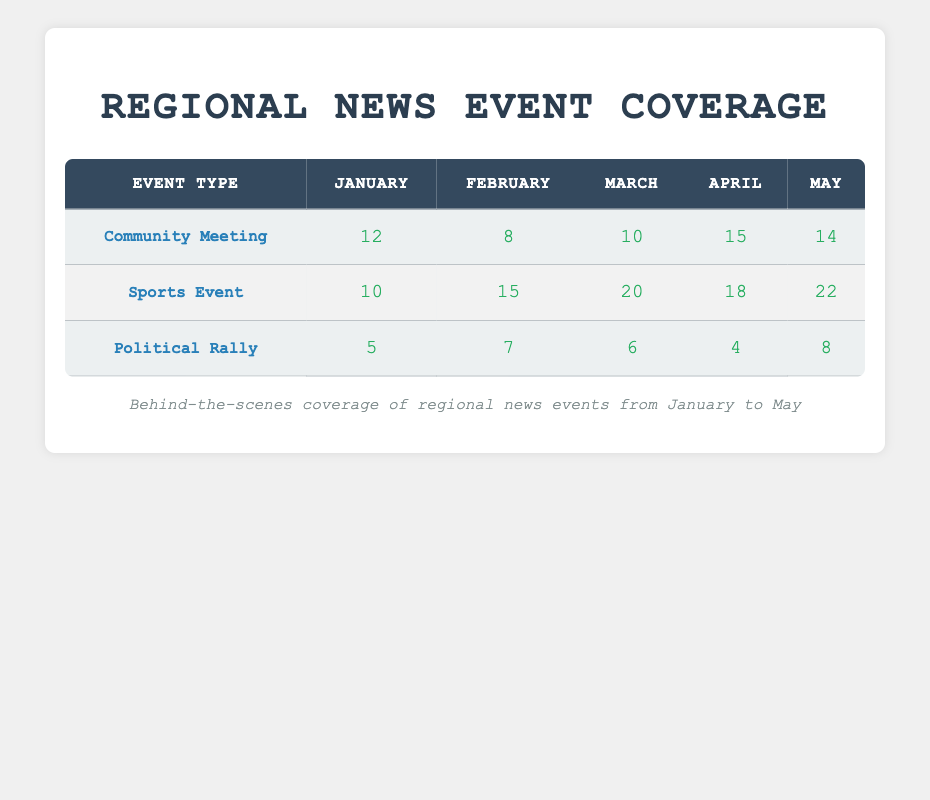What is the total count of Community Meetings in April? From the table, the count of Community Meetings in April is 15. There are no other counts to consider for this question.
Answer: 15 Which month had the highest number of Sports Events? Looking at the table, the counts for Sports Events by month are: January (10), February (15), March (20), April (18), and May (22). The highest count is 22 in May.
Answer: May How many more Community Meetings were covered in January compared to February? The count of Community Meetings in January is 12 and in February is 8. To find the difference, subtract February's count from January's count: 12 - 8 = 4.
Answer: 4 Did the number of Political Rallies increase from January to May? The counts for Political Rallies by month are: January (5), February (7), March (6), April (4), and May (8). Comparing these values, January to February shows an increase (from 5 to 7), then decreases in March and April, before increasing again in May. Hence, it did not consistently increase.
Answer: No What is the average count of Sports Events across all months? To find the average, we sum the counts for Sports Events from all months: 10 (January) + 15 (February) + 20 (March) + 18 (April) + 22 (May) = 85. There are 5 months, so we divide 85 by 5 to get an average of 17.
Answer: 17 How many total events were reported in March? The counts for all event types in March are: Community Meeting (10), Sports Event (20), and Political Rally (6). Adding these counts gives: 10 + 20 + 6 = 36.
Answer: 36 Which month had the least number of Political Rallies? By checking the table, the counts for Political Rallies by month are: January (5), February (7), March (6), April (4), and May (8). The least count is 4 in April.
Answer: April Was there a month where the count of Community Meetings exceeded 15? The counts for Community Meetings are: January (12), February (8), March (10), April (15), and May (14). Since 15 is the highest count and no month exceeds this, the answer is no.
Answer: No In which month did the total coverage count (sum of all events) exceed 40? Calculating the total counts for each month: January (12 + 10 + 5 = 27), February (8 + 15 + 7 = 30), March (10 + 20 + 6 = 36), April (15 + 18 + 4 = 37), and May (14 + 22 + 8 = 44). The only month where the coverage exceeds 40 is May.
Answer: May 